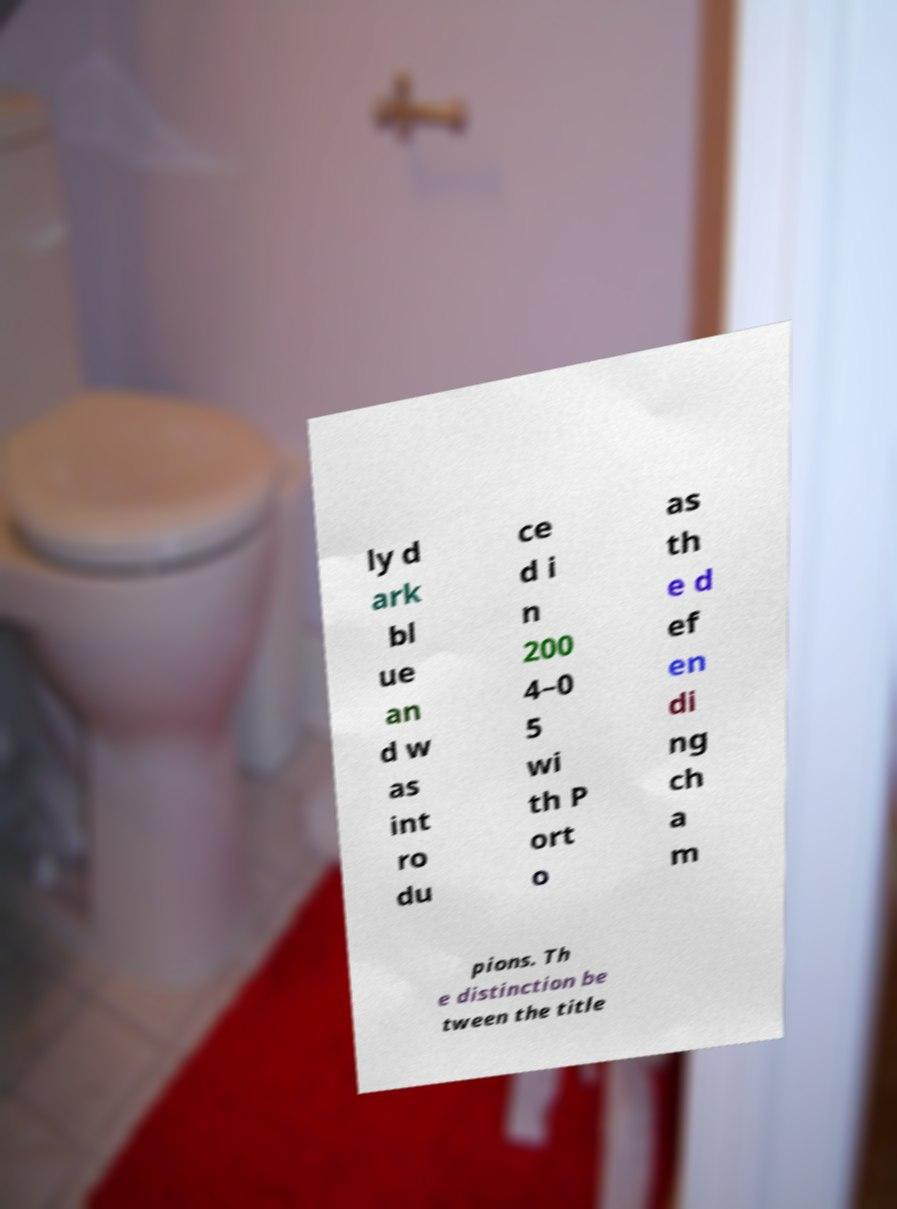There's text embedded in this image that I need extracted. Can you transcribe it verbatim? ly d ark bl ue an d w as int ro du ce d i n 200 4–0 5 wi th P ort o as th e d ef en di ng ch a m pions. Th e distinction be tween the title 